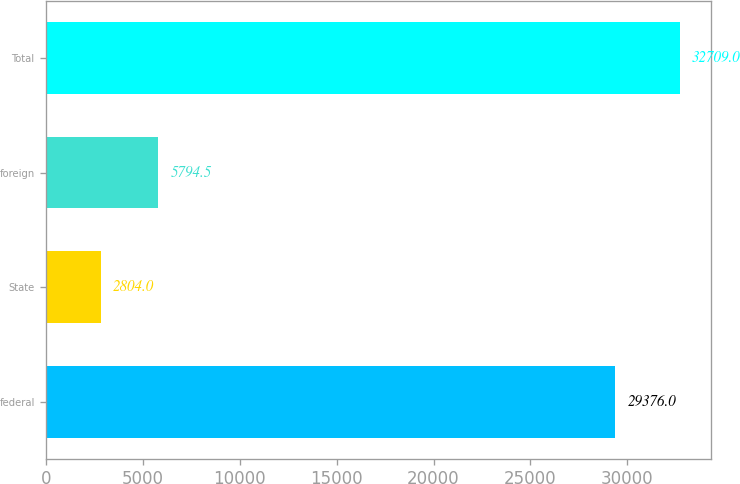<chart> <loc_0><loc_0><loc_500><loc_500><bar_chart><fcel>federal<fcel>State<fcel>foreign<fcel>Total<nl><fcel>29376<fcel>2804<fcel>5794.5<fcel>32709<nl></chart> 